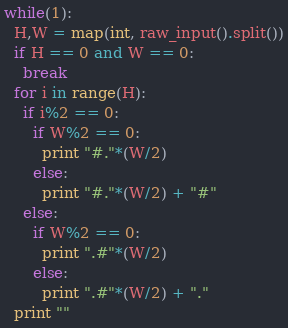<code> <loc_0><loc_0><loc_500><loc_500><_Python_>while(1):
  H,W = map(int, raw_input().split())
  if H == 0 and W == 0:
    break
  for i in range(H):
    if i%2 == 0:
      if W%2 == 0:
        print "#."*(W/2)
      else:
        print "#."*(W/2) + "#"
    else:
      if W%2 == 0:
        print ".#"*(W/2)
      else:
        print ".#"*(W/2) + "."
  print ""</code> 